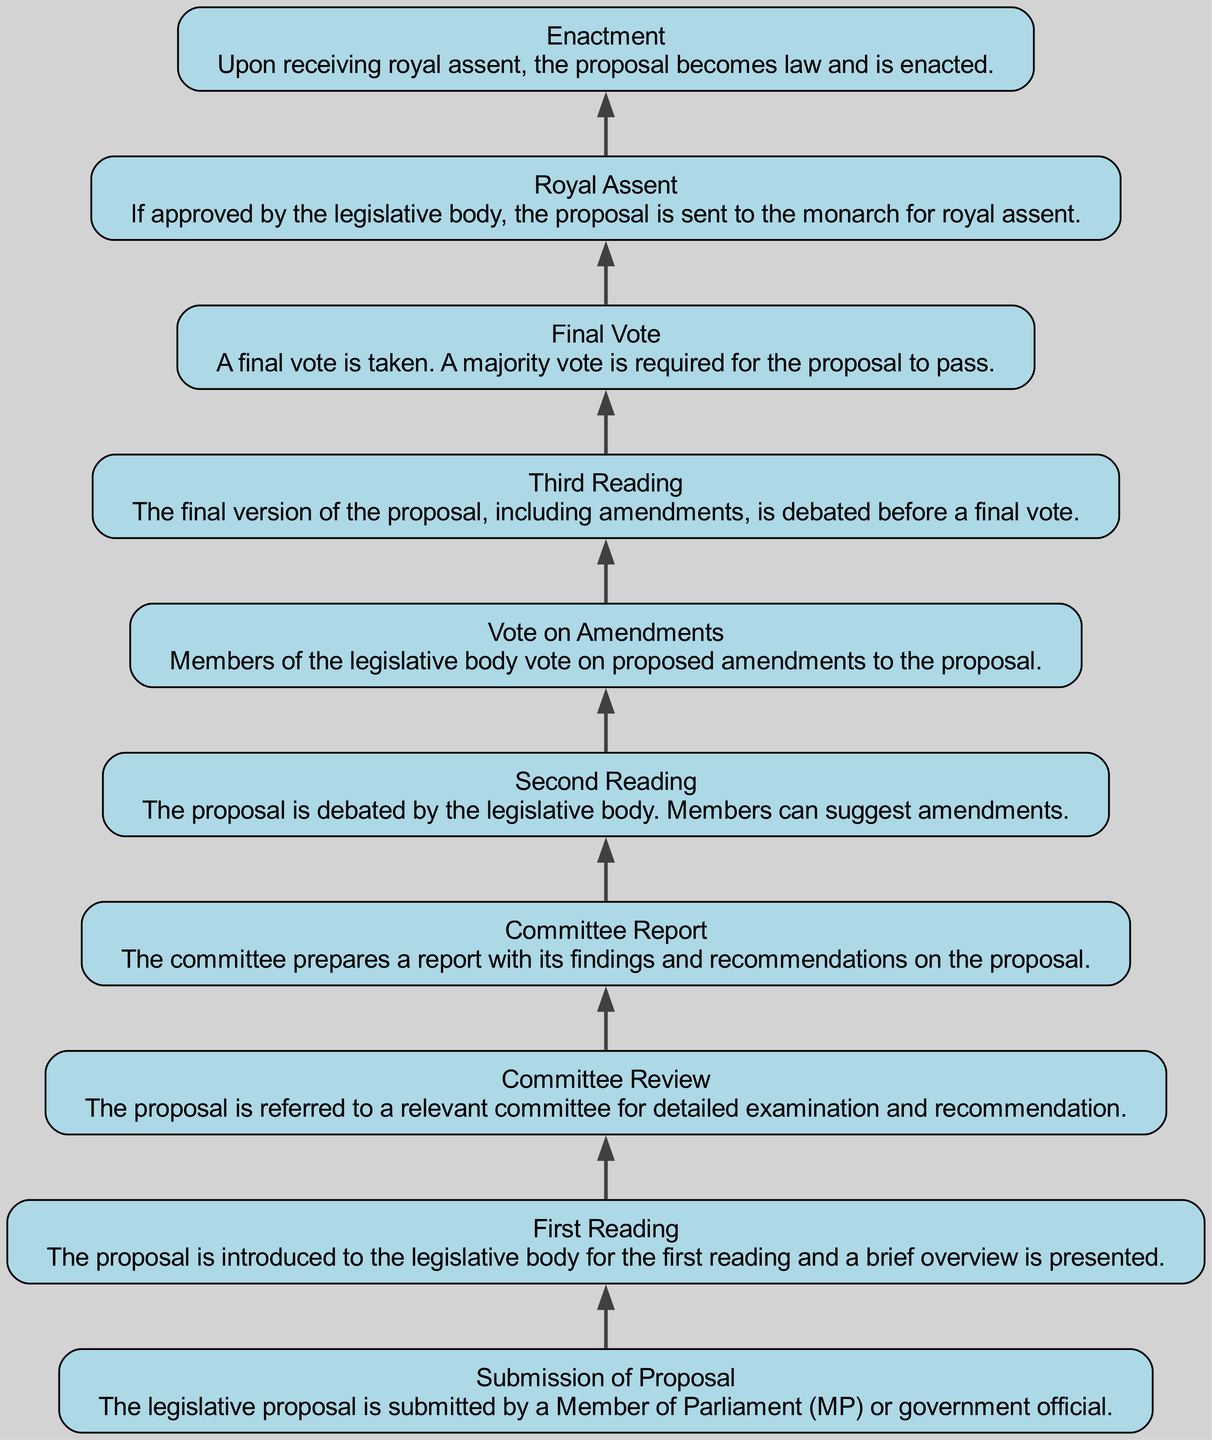What is the first step in the legislative proposal approval process? The first step is the "Submission of Proposal," where the legislative proposal is submitted by a Member of Parliament or government official.
Answer: Submission of Proposal How many nodes are in the diagram? The diagram contains 10 nodes, each representing a distinct step in the legislative proposal approval process.
Answer: 10 What follows the "Committee Review" step? After the "Committee Review," the next step is the "Committee Report," which details the findings and recommendations on the proposal.
Answer: Committee Report What is the final step in the process? The final step is "Enactment," which occurs when the proposal receives royal assent and becomes law.
Answer: Enactment What happens during the "Second Reading"? During the "Second Reading," the proposal is debated by the legislative body, and members can suggest amendments to the proposal.
Answer: Debate and amendments Which step requires a majority vote for approval? The "Final Vote" requires a majority vote from the legislative body for the proposal to pass.
Answer: Final Vote How many amendments can be voted on after the "Second Reading"? The number of amendments voted on is typically determined during the "Vote on Amendments," which is immediately after the "Second Reading." Since this step is a voting phase, the number can vary.
Answer: Varies Which step comes after receiving royal assent? After receiving royal assent, the process moves to "Enactment," which is when the proposal officially becomes law.
Answer: Enactment What is the purpose of the "Committee Report"? The "Committee Report" serves to provide detailed findings and recommendations from the committee regarding the legislative proposal being reviewed.
Answer: Findings and recommendations 